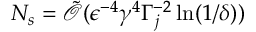Convert formula to latex. <formula><loc_0><loc_0><loc_500><loc_500>N _ { s } = \tilde { \mathcal { O } } ( \epsilon ^ { - 4 } \gamma ^ { 4 } \Gamma _ { j } ^ { - 2 } \ln ( 1 / \delta ) )</formula> 